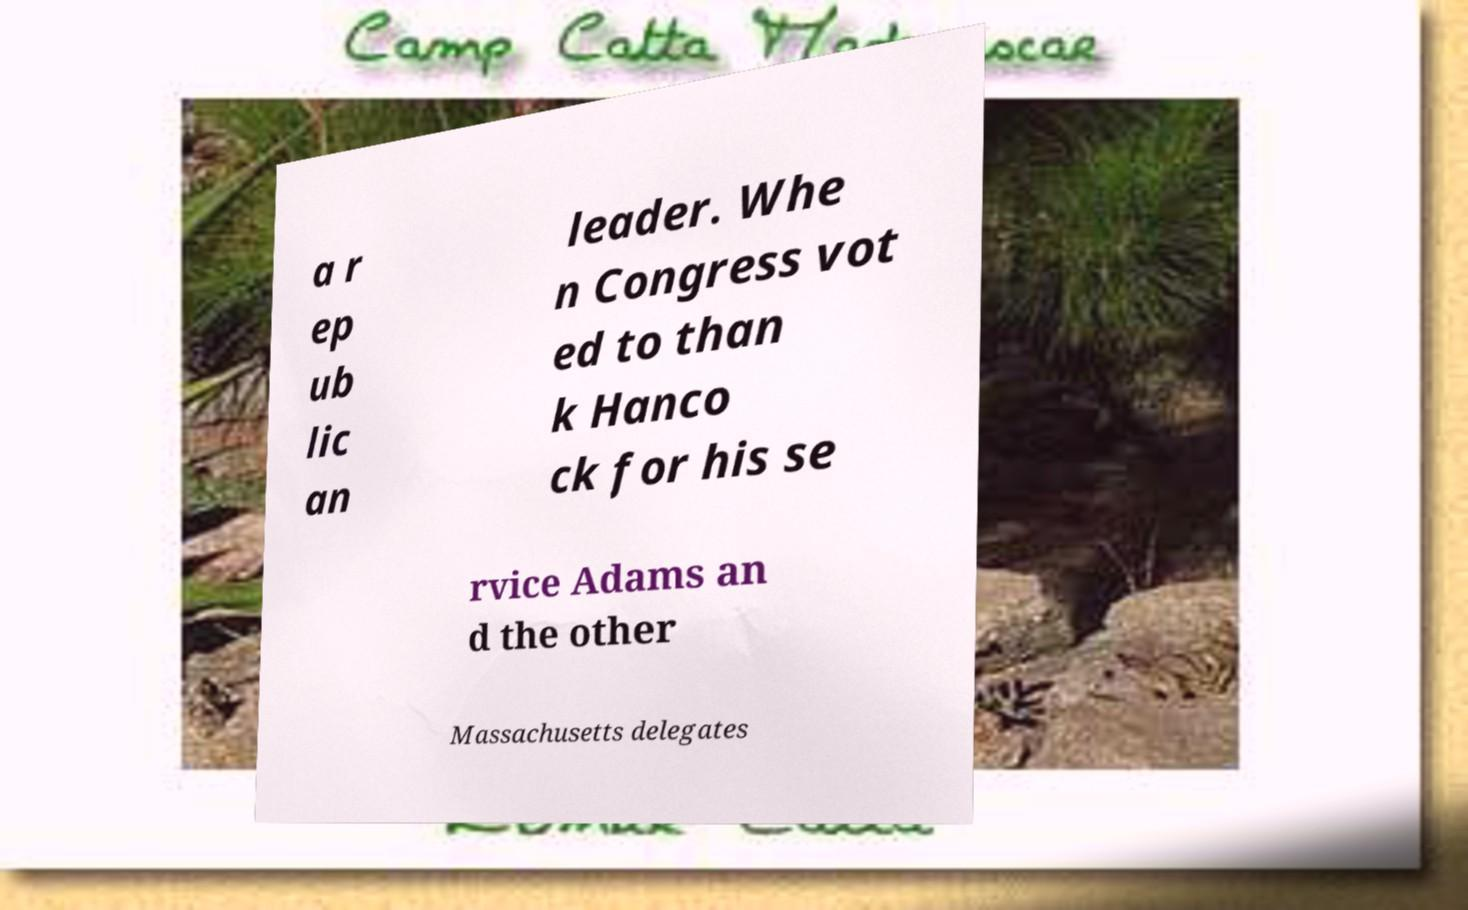I need the written content from this picture converted into text. Can you do that? a r ep ub lic an leader. Whe n Congress vot ed to than k Hanco ck for his se rvice Adams an d the other Massachusetts delegates 